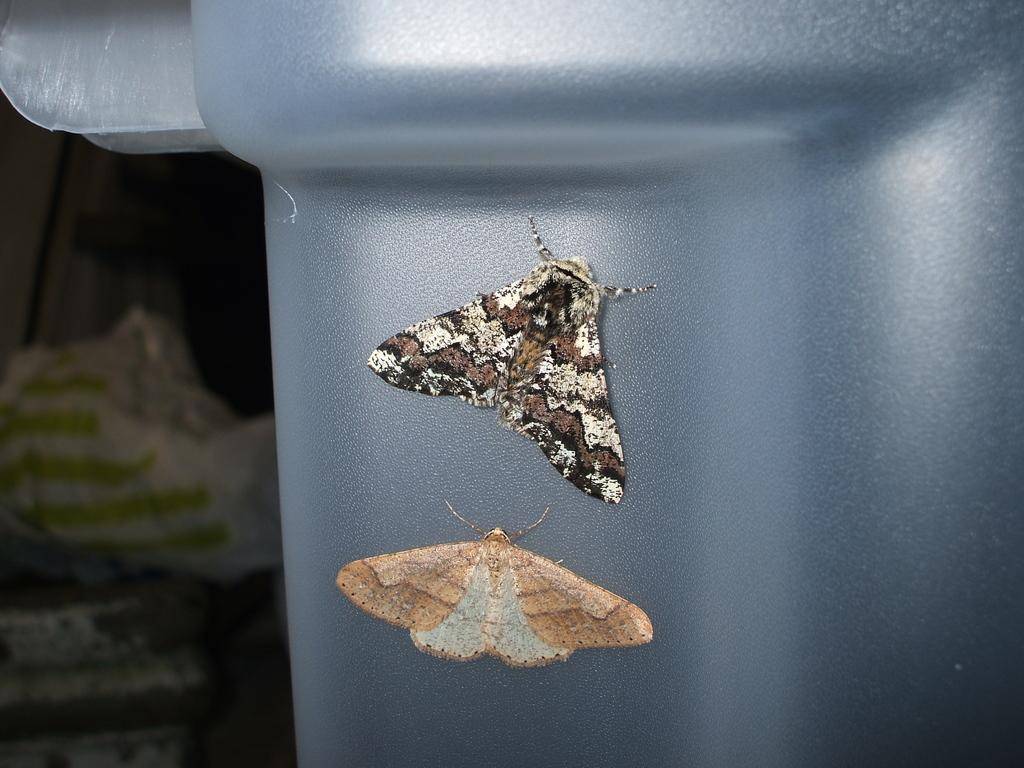What type of animals can be seen in the image? There are butterflies in the image. What colors are present on the butterflies? The butterflies have cream, brown, and black colors. What is the surface on which the butterflies are resting? The butterflies are on a grey surface. What color is the background of the image? The background of the image is black. How many books are the butterflies reading in the image? There are no books or reading activity present in the image; it features butterflies on a grey surface with a black background. 